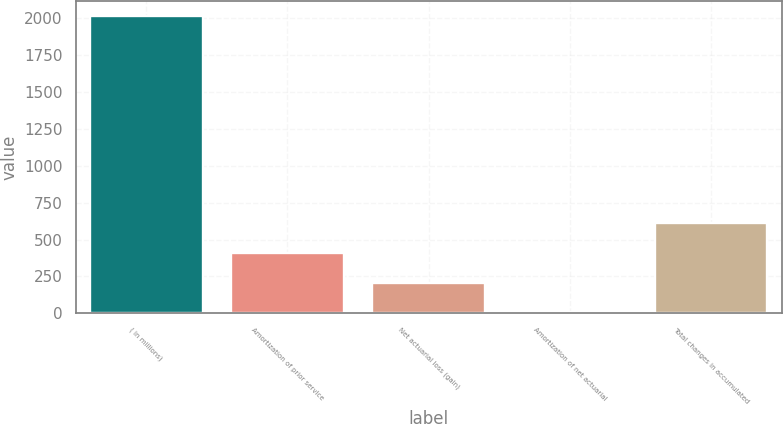<chart> <loc_0><loc_0><loc_500><loc_500><bar_chart><fcel>( in millions)<fcel>Amortization of prior service<fcel>Net actuarial loss (gain)<fcel>Amortization of net actuarial<fcel>Total changes in accumulated<nl><fcel>2016<fcel>408<fcel>207<fcel>6<fcel>609<nl></chart> 